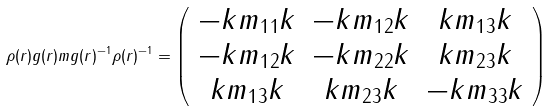<formula> <loc_0><loc_0><loc_500><loc_500>\rho ( r ) g ( r ) m g ( r ) ^ { - 1 } \rho ( r ) ^ { - 1 } = \left ( \begin{array} { c c c } - k m _ { 1 1 } k & - k m _ { 1 2 } k & k m _ { 1 3 } k \\ - k m _ { 1 2 } k & - k m _ { 2 2 } k & k m _ { 2 3 } k \\ k m _ { 1 3 } k & k m _ { 2 3 } k & - k m _ { 3 3 } k \end{array} \right )</formula> 